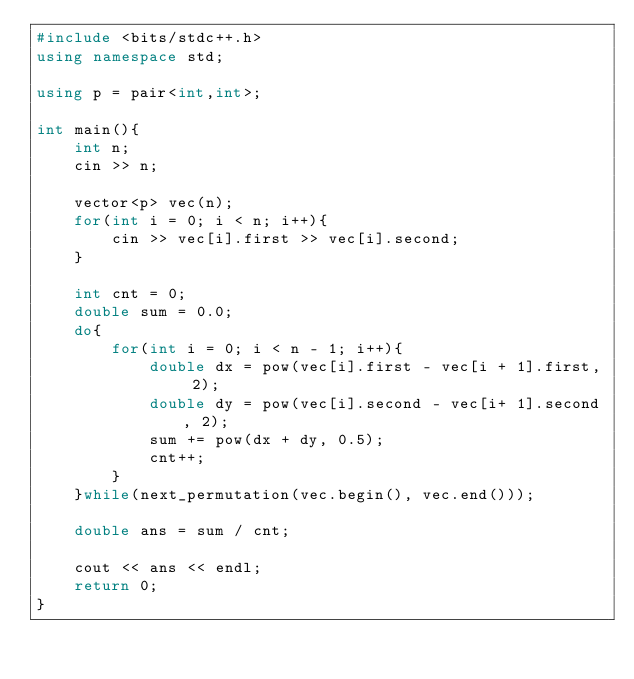Convert code to text. <code><loc_0><loc_0><loc_500><loc_500><_C++_>#include <bits/stdc++.h>
using namespace std;

using p = pair<int,int>;

int main(){
    int n;
    cin >> n;

    vector<p> vec(n);
    for(int i = 0; i < n; i++){
        cin >> vec[i].first >> vec[i].second;
    }

    int cnt = 0;
    double sum = 0.0;
    do{
        for(int i = 0; i < n - 1; i++){
            double dx = pow(vec[i].first - vec[i + 1].first, 2);
            double dy = pow(vec[i].second - vec[i+ 1].second, 2);
            sum += pow(dx + dy, 0.5);
            cnt++;
        }
    }while(next_permutation(vec.begin(), vec.end()));
   
    double ans = sum / cnt;

    cout << ans << endl;
    return 0;
}</code> 